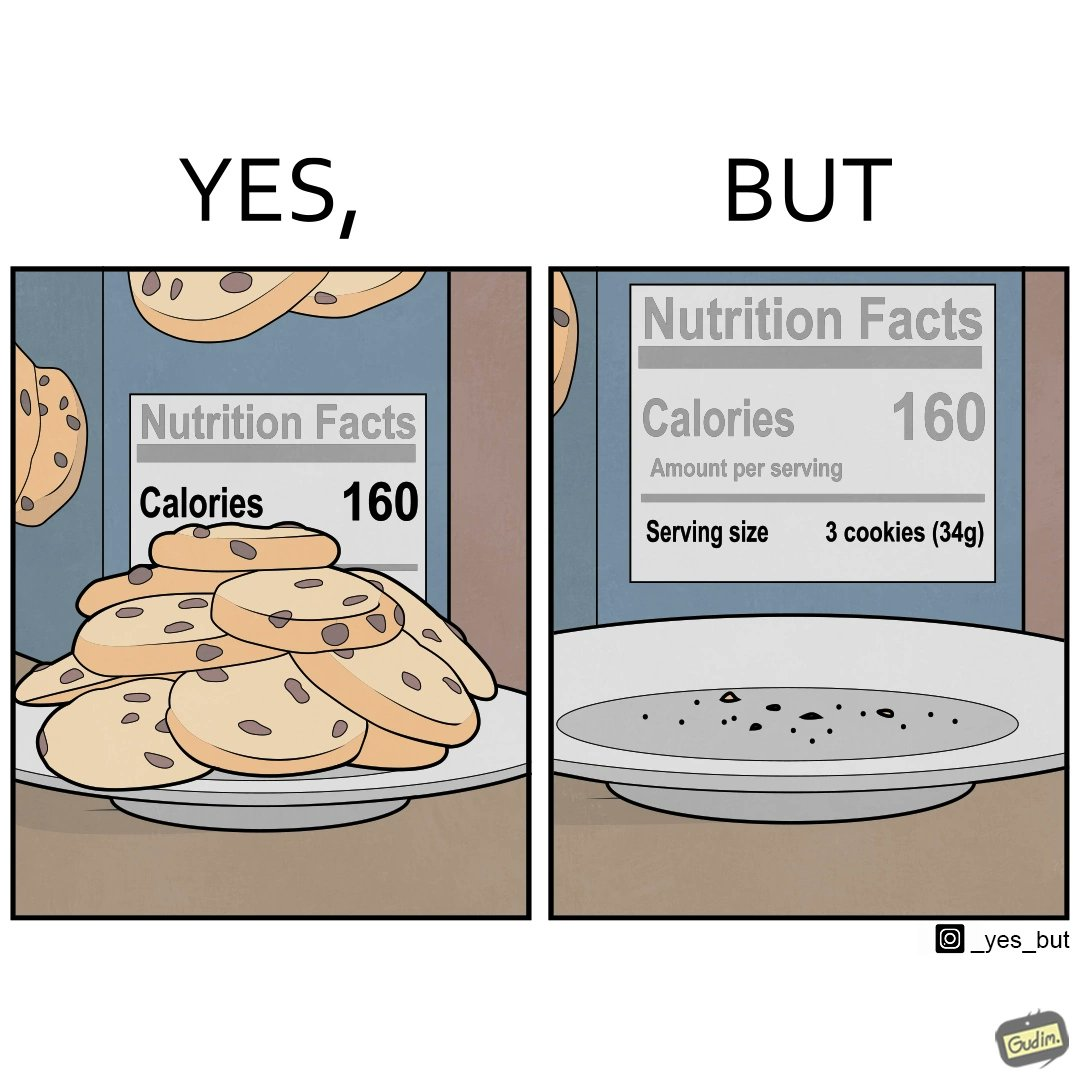Describe the satirical element in this image. The image is funny because the full plate of cookies is hiding the entire nutrition facts leading readers to believe that the entire box of cookies amounts to just 160 calories but when all the cookies are eaten and the plate is empty, the rest of the nutrition table is visible which tells that each serving of cookies amounts to 160 calories where one serving consists of 3 cookies. 